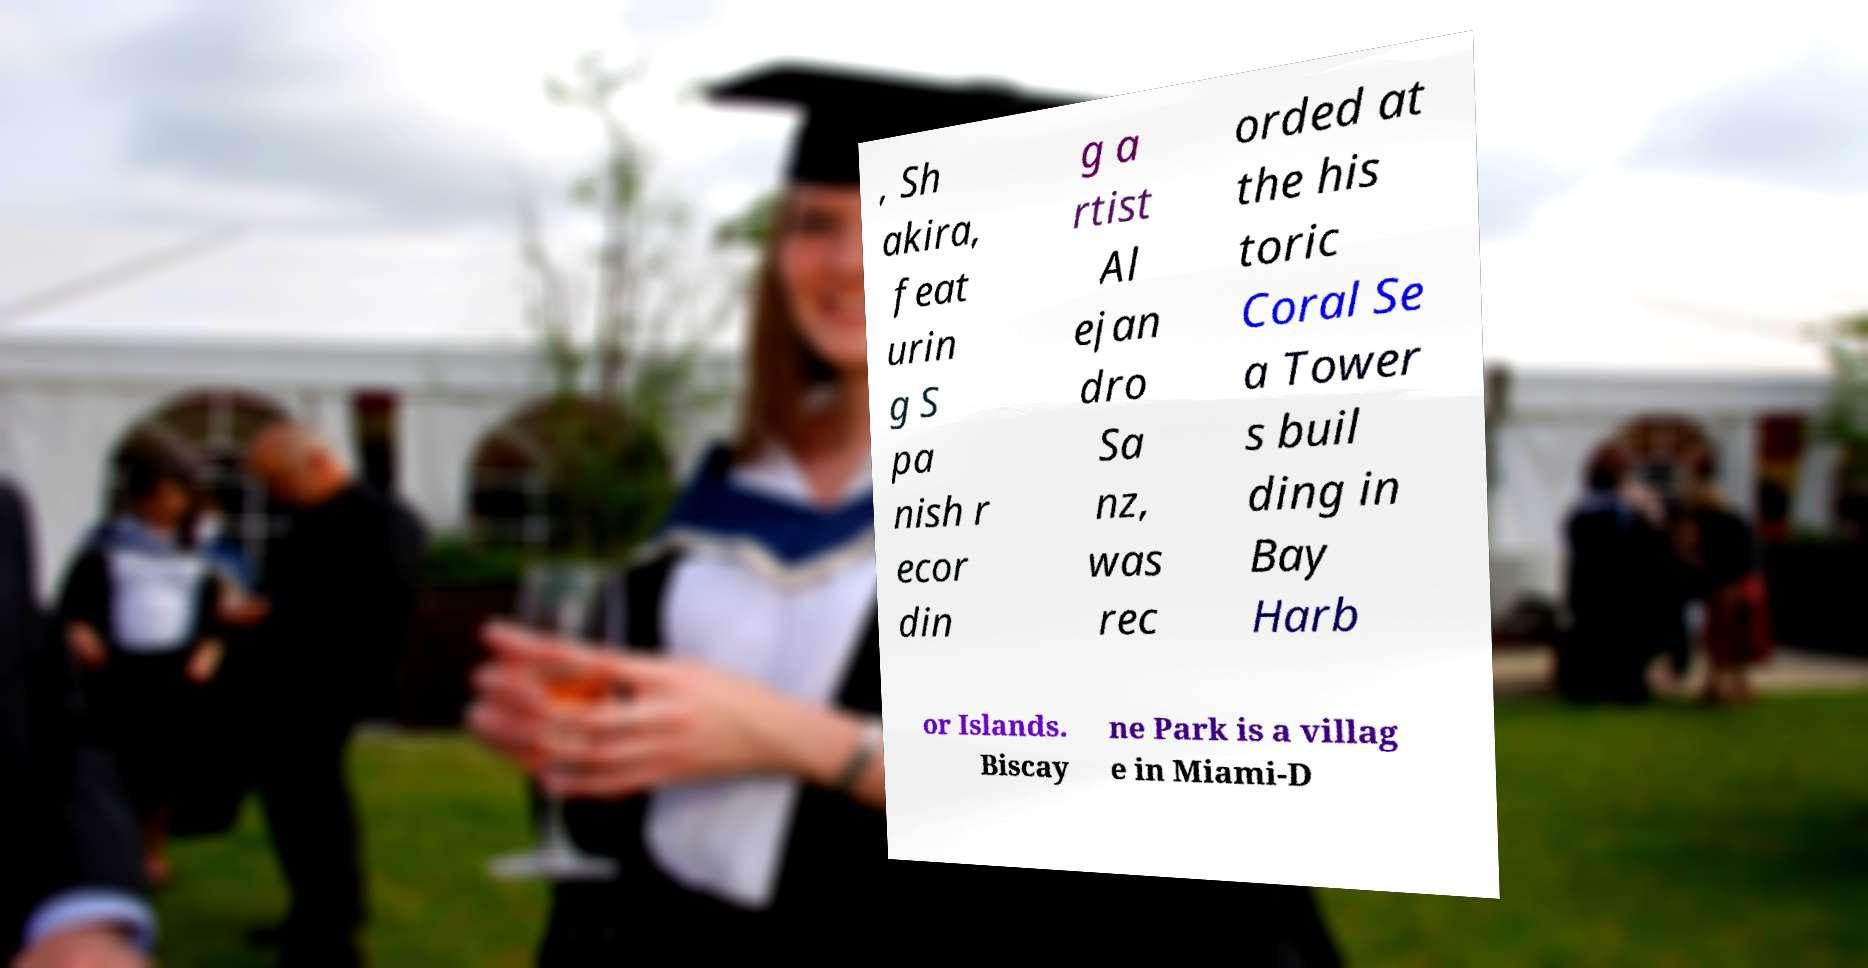Could you extract and type out the text from this image? , Sh akira, feat urin g S pa nish r ecor din g a rtist Al ejan dro Sa nz, was rec orded at the his toric Coral Se a Tower s buil ding in Bay Harb or Islands. Biscay ne Park is a villag e in Miami-D 